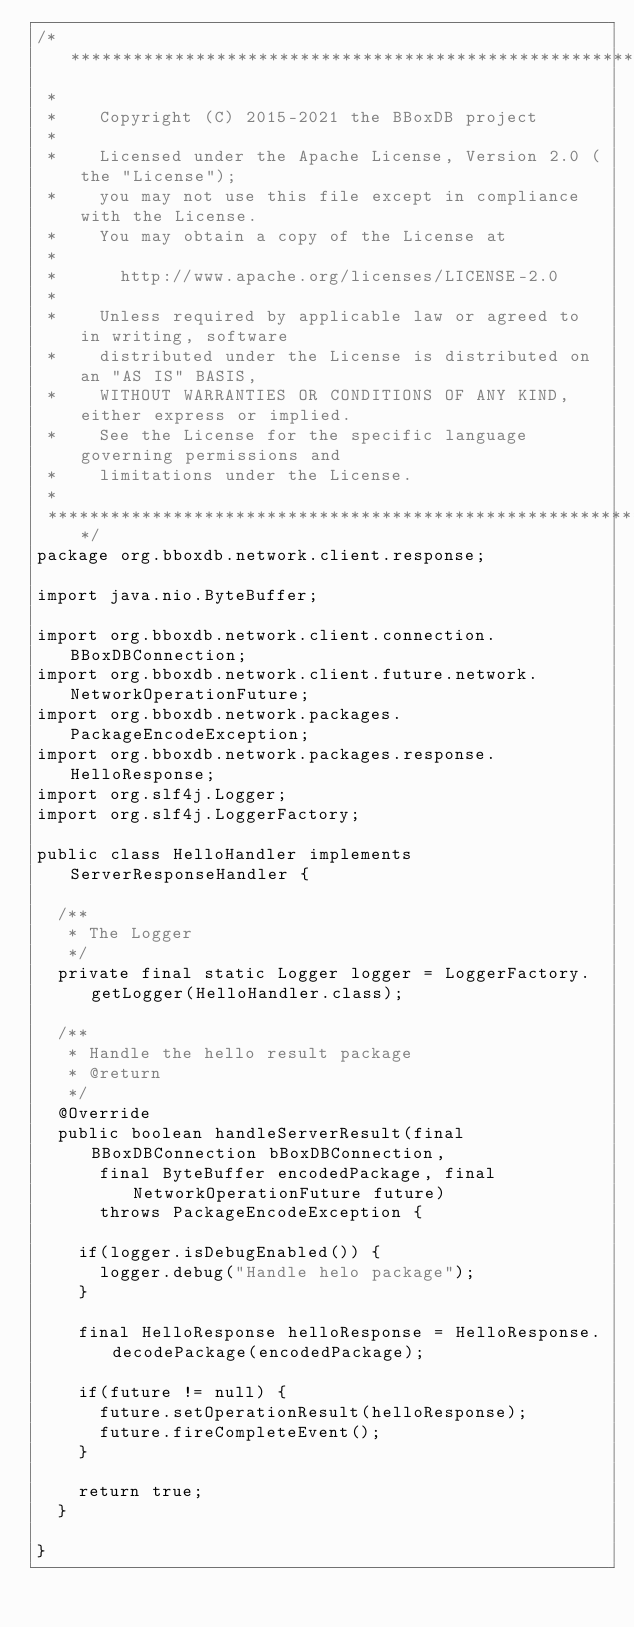Convert code to text. <code><loc_0><loc_0><loc_500><loc_500><_Java_>/*******************************************************************************
 *
 *    Copyright (C) 2015-2021 the BBoxDB project
 *  
 *    Licensed under the Apache License, Version 2.0 (the "License");
 *    you may not use this file except in compliance with the License.
 *    You may obtain a copy of the License at
 *  
 *      http://www.apache.org/licenses/LICENSE-2.0
 *  
 *    Unless required by applicable law or agreed to in writing, software
 *    distributed under the License is distributed on an "AS IS" BASIS,
 *    WITHOUT WARRANTIES OR CONDITIONS OF ANY KIND, either express or implied.
 *    See the License for the specific language governing permissions and
 *    limitations under the License. 
 *    
 *******************************************************************************/
package org.bboxdb.network.client.response;

import java.nio.ByteBuffer;

import org.bboxdb.network.client.connection.BBoxDBConnection;
import org.bboxdb.network.client.future.network.NetworkOperationFuture;
import org.bboxdb.network.packages.PackageEncodeException;
import org.bboxdb.network.packages.response.HelloResponse;
import org.slf4j.Logger;
import org.slf4j.LoggerFactory;

public class HelloHandler implements ServerResponseHandler {

	/**
	 * The Logger
	 */
	private final static Logger logger = LoggerFactory.getLogger(HelloHandler.class);

	/**
	 * Handle the hello result package
	 * @return 
	 */
	@Override
	public boolean handleServerResult(final BBoxDBConnection bBoxDBConnection, 
			final ByteBuffer encodedPackage, final NetworkOperationFuture future)
			throws PackageEncodeException {

		if(logger.isDebugEnabled()) {
			logger.debug("Handle helo package");
		}
				
		final HelloResponse helloResponse = HelloResponse.decodePackage(encodedPackage);
		
		if(future != null) {
			future.setOperationResult(helloResponse);
			future.fireCompleteEvent();
		}
		
		return true;
	}

}
</code> 